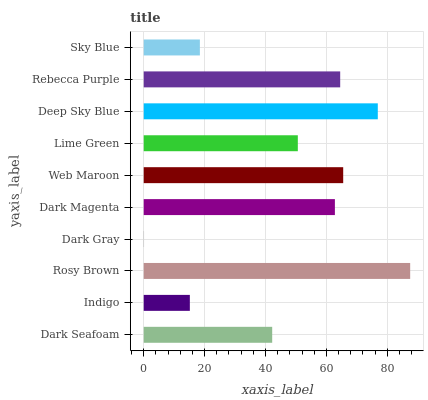Is Dark Gray the minimum?
Answer yes or no. Yes. Is Rosy Brown the maximum?
Answer yes or no. Yes. Is Indigo the minimum?
Answer yes or no. No. Is Indigo the maximum?
Answer yes or no. No. Is Dark Seafoam greater than Indigo?
Answer yes or no. Yes. Is Indigo less than Dark Seafoam?
Answer yes or no. Yes. Is Indigo greater than Dark Seafoam?
Answer yes or no. No. Is Dark Seafoam less than Indigo?
Answer yes or no. No. Is Dark Magenta the high median?
Answer yes or no. Yes. Is Lime Green the low median?
Answer yes or no. Yes. Is Lime Green the high median?
Answer yes or no. No. Is Rebecca Purple the low median?
Answer yes or no. No. 